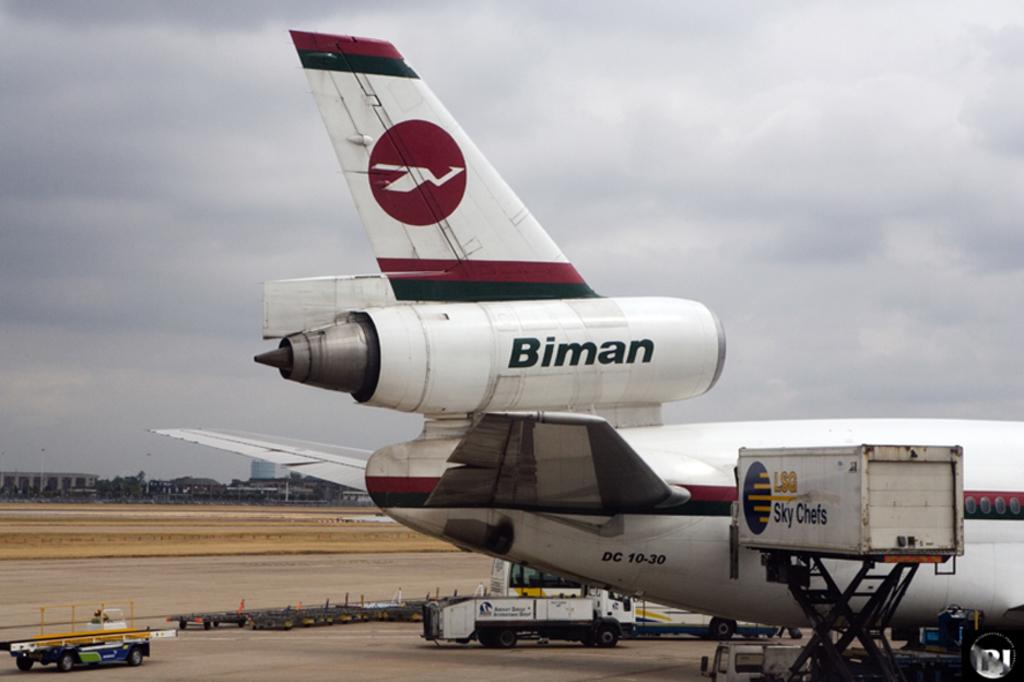<image>
Describe the image concisely. Biman wrote on a airplane that includes DC 10-30 sign. 